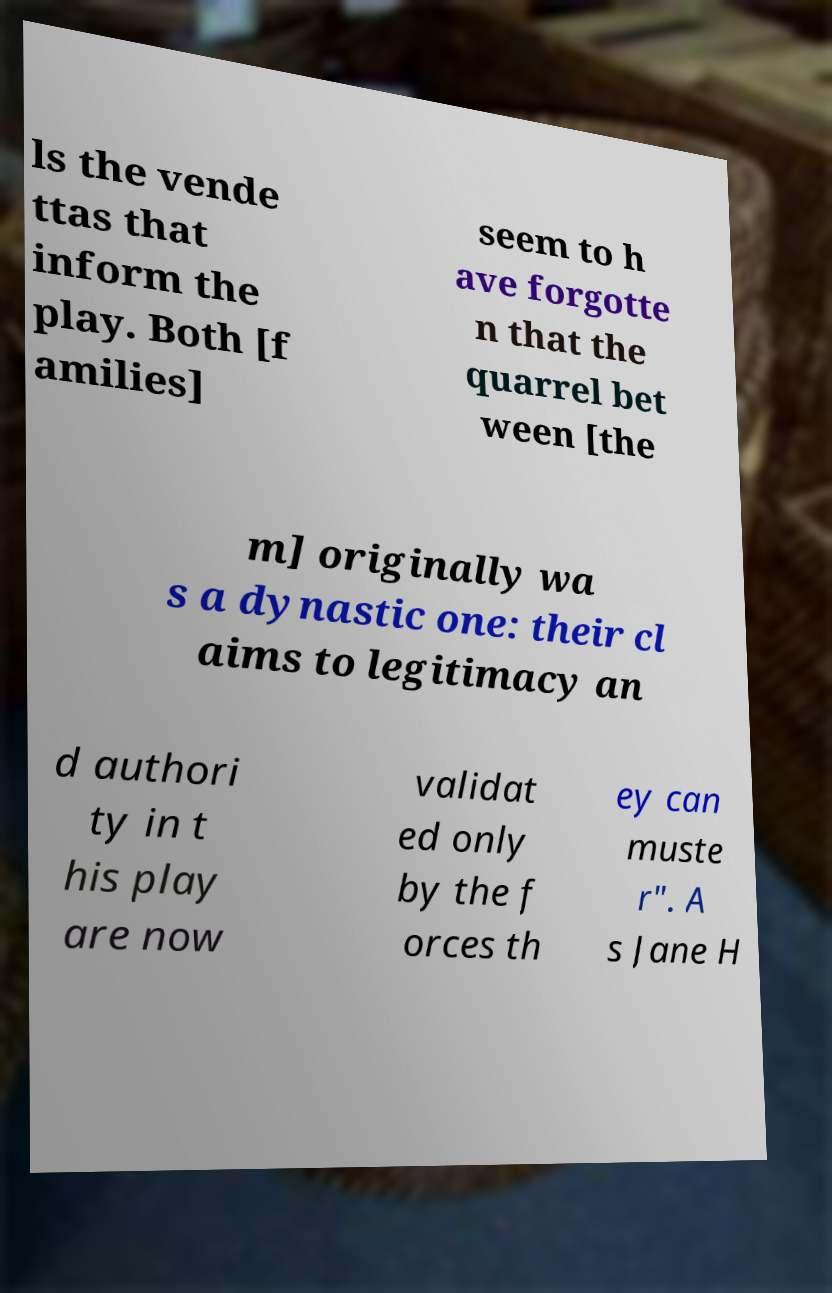For documentation purposes, I need the text within this image transcribed. Could you provide that? ls the vende ttas that inform the play. Both [f amilies] seem to h ave forgotte n that the quarrel bet ween [the m] originally wa s a dynastic one: their cl aims to legitimacy an d authori ty in t his play are now validat ed only by the f orces th ey can muste r". A s Jane H 